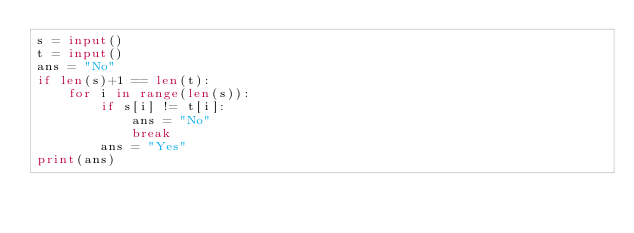Convert code to text. <code><loc_0><loc_0><loc_500><loc_500><_Python_>s = input()
t = input()
ans = "No"
if len(s)+1 == len(t):
    for i in range(len(s)):
        if s[i] != t[i]:
            ans = "No"
            break
        ans = "Yes"
print(ans)</code> 